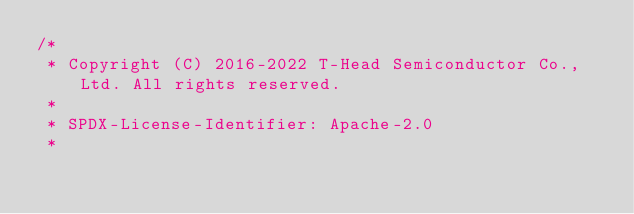Convert code to text. <code><loc_0><loc_0><loc_500><loc_500><_C_>/*
 * Copyright (C) 2016-2022 T-Head Semiconductor Co., Ltd. All rights reserved.
 *
 * SPDX-License-Identifier: Apache-2.0
 *</code> 